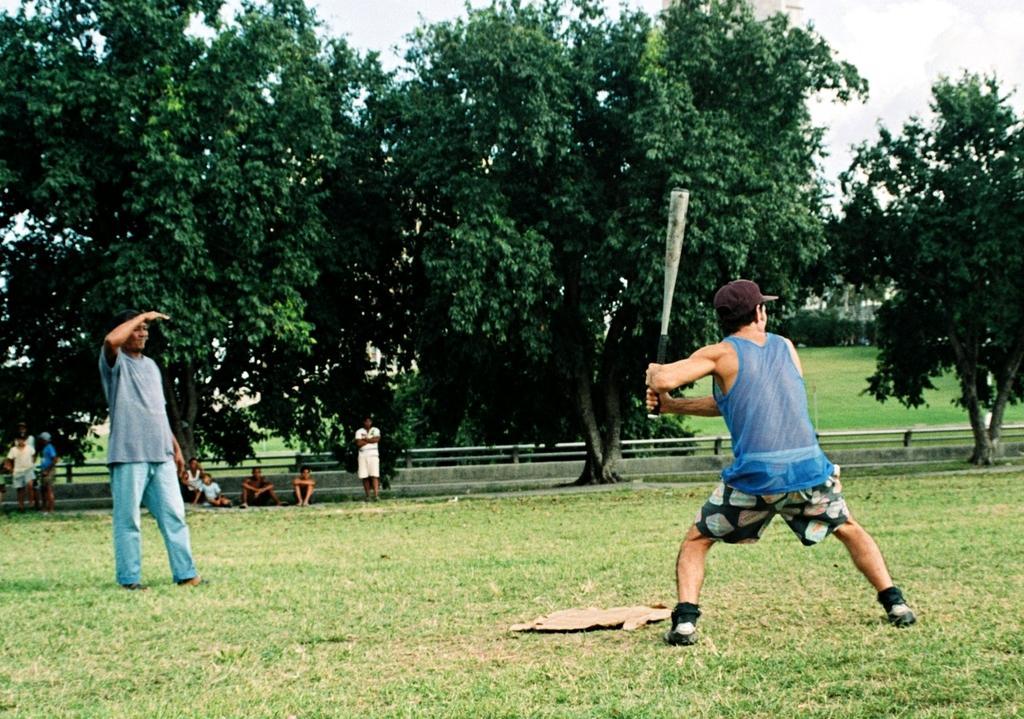How would you summarize this image in a sentence or two? In the picture we can see a grass surface on it, we can see a man playing a baseball holding a bat and in front of him we can see a man standing, and behind him we can see some children are sitting far away under the trees and behind the trees we can see railing and sky on the top of trees. 